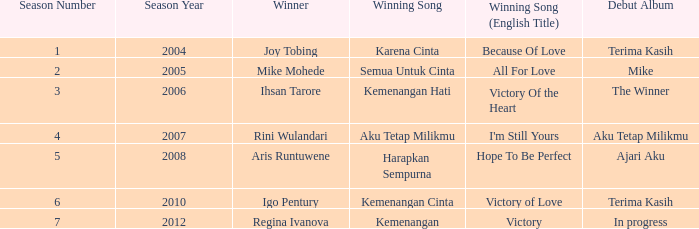Could you parse the entire table? {'header': ['Season Number', 'Season Year', 'Winner', 'Winning Song', 'Winning Song (English Title)', 'Debut Album'], 'rows': [['1', '2004', 'Joy Tobing', 'Karena Cinta', 'Because Of Love', 'Terima Kasih'], ['2', '2005', 'Mike Mohede', 'Semua Untuk Cinta', 'All For Love', 'Mike'], ['3', '2006', 'Ihsan Tarore', 'Kemenangan Hati', 'Victory Of the Heart', 'The Winner'], ['4', '2007', 'Rini Wulandari', 'Aku Tetap Milikmu', "I'm Still Yours", 'Aku Tetap Milikmu'], ['5', '2008', 'Aris Runtuwene', 'Harapkan Sempurna', 'Hope To Be Perfect', 'Ajari Aku'], ['6', '2010', 'Igo Pentury', 'Kemenangan Cinta', 'Victory of Love', 'Terima Kasih'], ['7', '2012', 'Regina Ivanova', 'Kemenangan', 'Victory', 'In progress']]} Which album debuted in season 2 (2005)? Mike. 